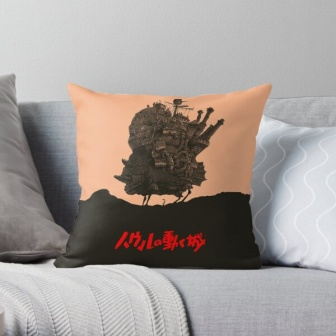Describe the atmosphere created by the decor in this image. The atmosphere created by the decor in this image is one of comfort and whimsy. The gray couch and blanket provide a neutral and soothing background, while the color-blocked pillow with its imaginative castle illustration and reference to 'Miyazaki' adds a touch of fantasy and artistry. The overall effect is a cozy space that invites relaxation but also stimulates the imagination. 